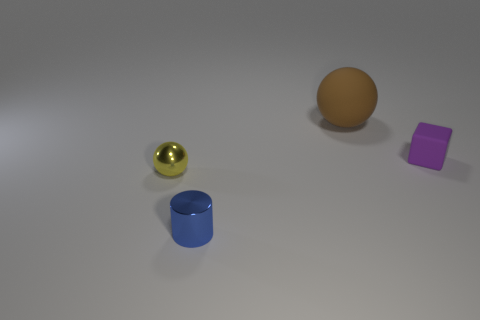Subtract all yellow spheres. How many spheres are left? 1 Subtract 1 spheres. How many spheres are left? 1 Add 3 cyan objects. How many objects exist? 7 Subtract all cylinders. How many objects are left? 3 Subtract all brown things. Subtract all large matte balls. How many objects are left? 2 Add 4 brown spheres. How many brown spheres are left? 5 Add 4 small yellow objects. How many small yellow objects exist? 5 Subtract 0 green balls. How many objects are left? 4 Subtract all yellow blocks. Subtract all cyan balls. How many blocks are left? 1 Subtract all cyan cylinders. How many brown spheres are left? 1 